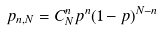<formula> <loc_0><loc_0><loc_500><loc_500>p _ { n , N } = C _ { N } ^ { n } p ^ { n } ( 1 - p ) ^ { N - n } \,</formula> 